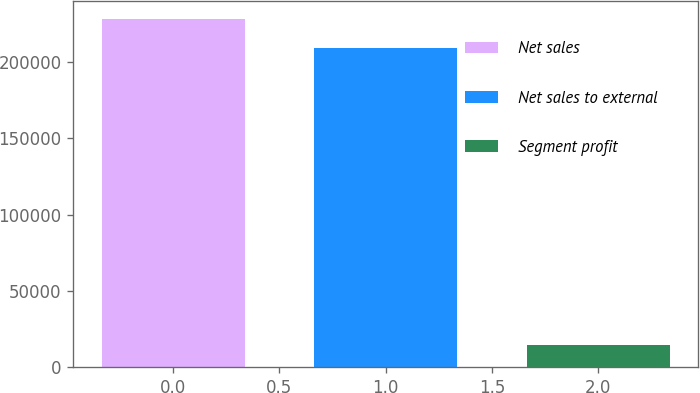Convert chart. <chart><loc_0><loc_0><loc_500><loc_500><bar_chart><fcel>Net sales<fcel>Net sales to external<fcel>Segment profit<nl><fcel>228366<fcel>208895<fcel>14745<nl></chart> 